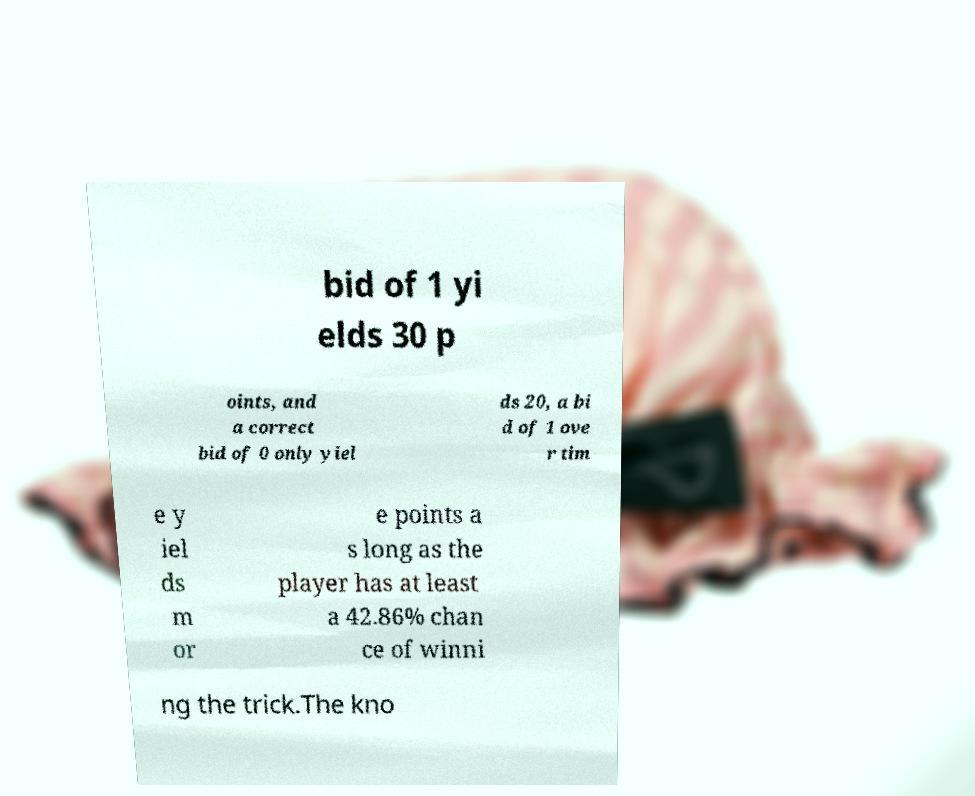Could you assist in decoding the text presented in this image and type it out clearly? bid of 1 yi elds 30 p oints, and a correct bid of 0 only yiel ds 20, a bi d of 1 ove r tim e y iel ds m or e points a s long as the player has at least a 42.86% chan ce of winni ng the trick.The kno 